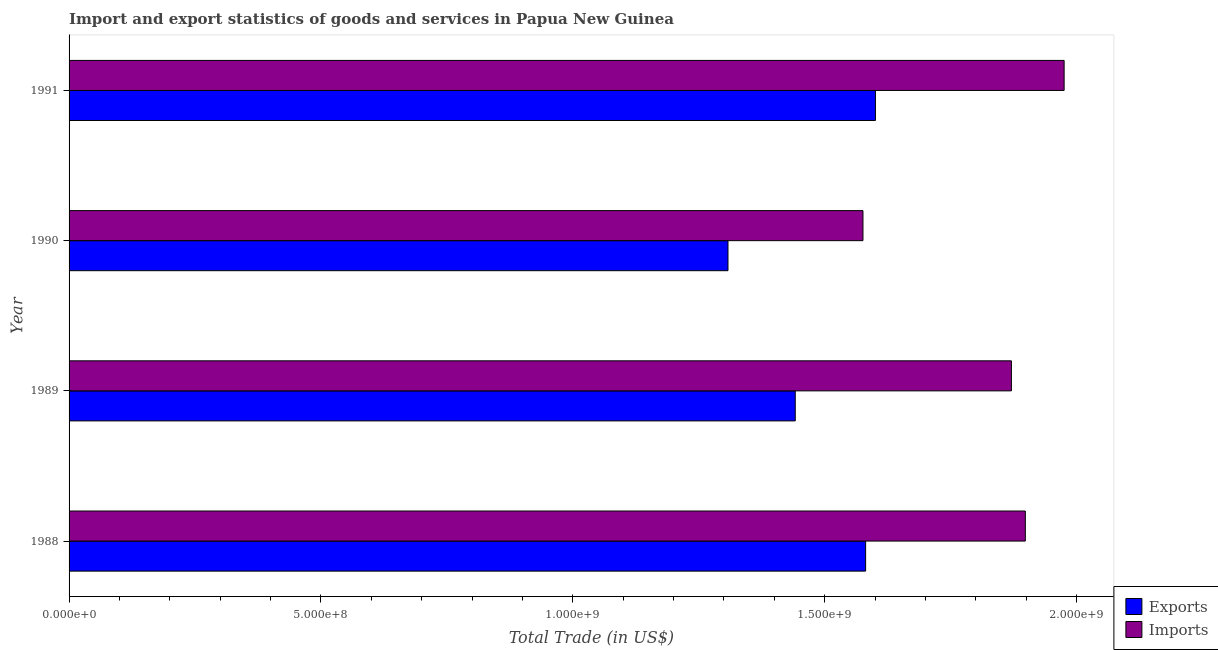How many different coloured bars are there?
Your response must be concise. 2. Are the number of bars per tick equal to the number of legend labels?
Offer a terse response. Yes. How many bars are there on the 1st tick from the top?
Keep it short and to the point. 2. What is the imports of goods and services in 1990?
Keep it short and to the point. 1.58e+09. Across all years, what is the maximum export of goods and services?
Provide a short and direct response. 1.60e+09. Across all years, what is the minimum export of goods and services?
Ensure brevity in your answer.  1.31e+09. What is the total imports of goods and services in the graph?
Offer a very short reply. 7.32e+09. What is the difference between the imports of goods and services in 1988 and that in 1991?
Your answer should be very brief. -7.70e+07. What is the difference between the export of goods and services in 1989 and the imports of goods and services in 1990?
Ensure brevity in your answer.  -1.34e+08. What is the average export of goods and services per year?
Your response must be concise. 1.48e+09. In the year 1989, what is the difference between the export of goods and services and imports of goods and services?
Ensure brevity in your answer.  -4.29e+08. What is the ratio of the export of goods and services in 1988 to that in 1989?
Give a very brief answer. 1.1. What is the difference between the highest and the second highest export of goods and services?
Provide a short and direct response. 1.95e+07. What is the difference between the highest and the lowest export of goods and services?
Give a very brief answer. 2.93e+08. In how many years, is the export of goods and services greater than the average export of goods and services taken over all years?
Your answer should be very brief. 2. What does the 1st bar from the top in 1991 represents?
Offer a very short reply. Imports. What does the 1st bar from the bottom in 1989 represents?
Give a very brief answer. Exports. Does the graph contain any zero values?
Your response must be concise. No. Does the graph contain grids?
Provide a succinct answer. No. Where does the legend appear in the graph?
Your answer should be compact. Bottom right. How many legend labels are there?
Your answer should be compact. 2. How are the legend labels stacked?
Ensure brevity in your answer.  Vertical. What is the title of the graph?
Provide a succinct answer. Import and export statistics of goods and services in Papua New Guinea. What is the label or title of the X-axis?
Offer a very short reply. Total Trade (in US$). What is the Total Trade (in US$) of Exports in 1988?
Your answer should be very brief. 1.58e+09. What is the Total Trade (in US$) of Imports in 1988?
Your answer should be very brief. 1.90e+09. What is the Total Trade (in US$) in Exports in 1989?
Your answer should be very brief. 1.44e+09. What is the Total Trade (in US$) in Imports in 1989?
Your answer should be compact. 1.87e+09. What is the Total Trade (in US$) of Exports in 1990?
Your answer should be very brief. 1.31e+09. What is the Total Trade (in US$) of Imports in 1990?
Provide a short and direct response. 1.58e+09. What is the Total Trade (in US$) of Exports in 1991?
Keep it short and to the point. 1.60e+09. What is the Total Trade (in US$) of Imports in 1991?
Ensure brevity in your answer.  1.98e+09. Across all years, what is the maximum Total Trade (in US$) in Exports?
Offer a very short reply. 1.60e+09. Across all years, what is the maximum Total Trade (in US$) of Imports?
Ensure brevity in your answer.  1.98e+09. Across all years, what is the minimum Total Trade (in US$) of Exports?
Provide a succinct answer. 1.31e+09. Across all years, what is the minimum Total Trade (in US$) of Imports?
Your answer should be compact. 1.58e+09. What is the total Total Trade (in US$) of Exports in the graph?
Your answer should be very brief. 5.93e+09. What is the total Total Trade (in US$) of Imports in the graph?
Your answer should be compact. 7.32e+09. What is the difference between the Total Trade (in US$) of Exports in 1988 and that in 1989?
Keep it short and to the point. 1.40e+08. What is the difference between the Total Trade (in US$) of Imports in 1988 and that in 1989?
Make the answer very short. 2.76e+07. What is the difference between the Total Trade (in US$) in Exports in 1988 and that in 1990?
Your answer should be very brief. 2.73e+08. What is the difference between the Total Trade (in US$) in Imports in 1988 and that in 1990?
Ensure brevity in your answer.  3.22e+08. What is the difference between the Total Trade (in US$) in Exports in 1988 and that in 1991?
Keep it short and to the point. -1.95e+07. What is the difference between the Total Trade (in US$) of Imports in 1988 and that in 1991?
Offer a terse response. -7.70e+07. What is the difference between the Total Trade (in US$) of Exports in 1989 and that in 1990?
Offer a terse response. 1.34e+08. What is the difference between the Total Trade (in US$) of Imports in 1989 and that in 1990?
Offer a terse response. 2.95e+08. What is the difference between the Total Trade (in US$) in Exports in 1989 and that in 1991?
Offer a very short reply. -1.59e+08. What is the difference between the Total Trade (in US$) in Imports in 1989 and that in 1991?
Offer a very short reply. -1.05e+08. What is the difference between the Total Trade (in US$) of Exports in 1990 and that in 1991?
Your answer should be very brief. -2.93e+08. What is the difference between the Total Trade (in US$) of Imports in 1990 and that in 1991?
Offer a very short reply. -3.99e+08. What is the difference between the Total Trade (in US$) of Exports in 1988 and the Total Trade (in US$) of Imports in 1989?
Ensure brevity in your answer.  -2.89e+08. What is the difference between the Total Trade (in US$) in Exports in 1988 and the Total Trade (in US$) in Imports in 1990?
Your response must be concise. 5.29e+06. What is the difference between the Total Trade (in US$) of Exports in 1988 and the Total Trade (in US$) of Imports in 1991?
Provide a succinct answer. -3.94e+08. What is the difference between the Total Trade (in US$) of Exports in 1989 and the Total Trade (in US$) of Imports in 1990?
Your answer should be very brief. -1.34e+08. What is the difference between the Total Trade (in US$) in Exports in 1989 and the Total Trade (in US$) in Imports in 1991?
Keep it short and to the point. -5.34e+08. What is the difference between the Total Trade (in US$) in Exports in 1990 and the Total Trade (in US$) in Imports in 1991?
Ensure brevity in your answer.  -6.67e+08. What is the average Total Trade (in US$) in Exports per year?
Provide a short and direct response. 1.48e+09. What is the average Total Trade (in US$) of Imports per year?
Provide a succinct answer. 1.83e+09. In the year 1988, what is the difference between the Total Trade (in US$) in Exports and Total Trade (in US$) in Imports?
Give a very brief answer. -3.17e+08. In the year 1989, what is the difference between the Total Trade (in US$) in Exports and Total Trade (in US$) in Imports?
Your answer should be compact. -4.29e+08. In the year 1990, what is the difference between the Total Trade (in US$) in Exports and Total Trade (in US$) in Imports?
Your response must be concise. -2.68e+08. In the year 1991, what is the difference between the Total Trade (in US$) in Exports and Total Trade (in US$) in Imports?
Offer a terse response. -3.75e+08. What is the ratio of the Total Trade (in US$) of Exports in 1988 to that in 1989?
Your response must be concise. 1.1. What is the ratio of the Total Trade (in US$) of Imports in 1988 to that in 1989?
Provide a succinct answer. 1.01. What is the ratio of the Total Trade (in US$) of Exports in 1988 to that in 1990?
Provide a succinct answer. 1.21. What is the ratio of the Total Trade (in US$) of Imports in 1988 to that in 1990?
Provide a short and direct response. 1.2. What is the ratio of the Total Trade (in US$) of Exports in 1988 to that in 1991?
Offer a very short reply. 0.99. What is the ratio of the Total Trade (in US$) in Imports in 1988 to that in 1991?
Provide a short and direct response. 0.96. What is the ratio of the Total Trade (in US$) of Exports in 1989 to that in 1990?
Provide a short and direct response. 1.1. What is the ratio of the Total Trade (in US$) in Imports in 1989 to that in 1990?
Ensure brevity in your answer.  1.19. What is the ratio of the Total Trade (in US$) in Exports in 1989 to that in 1991?
Your answer should be very brief. 0.9. What is the ratio of the Total Trade (in US$) of Imports in 1989 to that in 1991?
Your response must be concise. 0.95. What is the ratio of the Total Trade (in US$) in Exports in 1990 to that in 1991?
Make the answer very short. 0.82. What is the ratio of the Total Trade (in US$) in Imports in 1990 to that in 1991?
Keep it short and to the point. 0.8. What is the difference between the highest and the second highest Total Trade (in US$) in Exports?
Your answer should be compact. 1.95e+07. What is the difference between the highest and the second highest Total Trade (in US$) of Imports?
Your answer should be very brief. 7.70e+07. What is the difference between the highest and the lowest Total Trade (in US$) in Exports?
Your answer should be compact. 2.93e+08. What is the difference between the highest and the lowest Total Trade (in US$) in Imports?
Ensure brevity in your answer.  3.99e+08. 